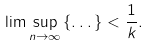Convert formula to latex. <formula><loc_0><loc_0><loc_500><loc_500>\lim \sup _ { n \rightarrow \infty } \left \{ \dots \right \} < \frac { 1 } { k } .</formula> 